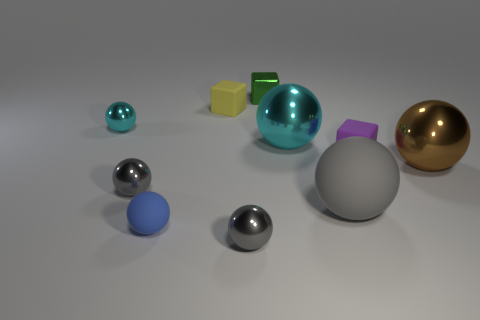There is a gray thing that is the same size as the brown thing; what is its shape?
Offer a very short reply. Sphere. There is a large cyan sphere; are there any tiny purple cubes to the right of it?
Offer a terse response. Yes. Does the small gray ball behind the tiny blue rubber thing have the same material as the large ball that is behind the big brown thing?
Provide a short and direct response. Yes. How many green blocks are the same size as the brown shiny sphere?
Provide a succinct answer. 0. There is a object behind the yellow block; what is its material?
Make the answer very short. Metal. How many other large things have the same shape as the big brown thing?
Your answer should be very brief. 2. The large gray thing that is the same material as the blue ball is what shape?
Offer a very short reply. Sphere. The large metallic thing on the left side of the rubber cube in front of the cyan object that is to the right of the green thing is what shape?
Your answer should be compact. Sphere. Is the number of tiny cyan metallic objects greater than the number of blue metal objects?
Ensure brevity in your answer.  Yes. There is a yellow thing that is the same shape as the green metal object; what is its material?
Give a very brief answer. Rubber. 